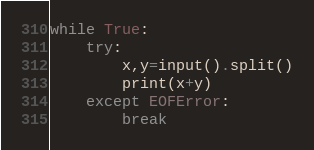<code> <loc_0><loc_0><loc_500><loc_500><_Python_>while True:
	try:
		x,y=input().split()
		print(x+y)
	except EOFError:
		break</code> 